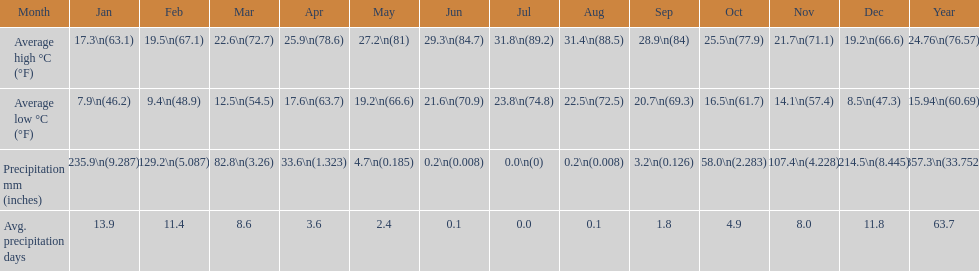What is the month with the lowest average low in haifa? January. 